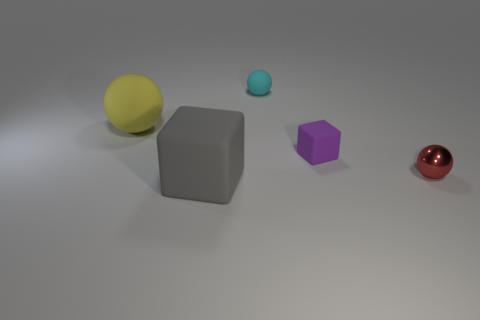Add 3 gray cubes. How many objects exist? 8 Subtract all spheres. How many objects are left? 2 Add 5 tiny matte objects. How many tiny matte objects exist? 7 Subtract 0 cyan cylinders. How many objects are left? 5 Subtract all big cyan rubber cylinders. Subtract all large matte balls. How many objects are left? 4 Add 5 big yellow matte balls. How many big yellow matte balls are left? 6 